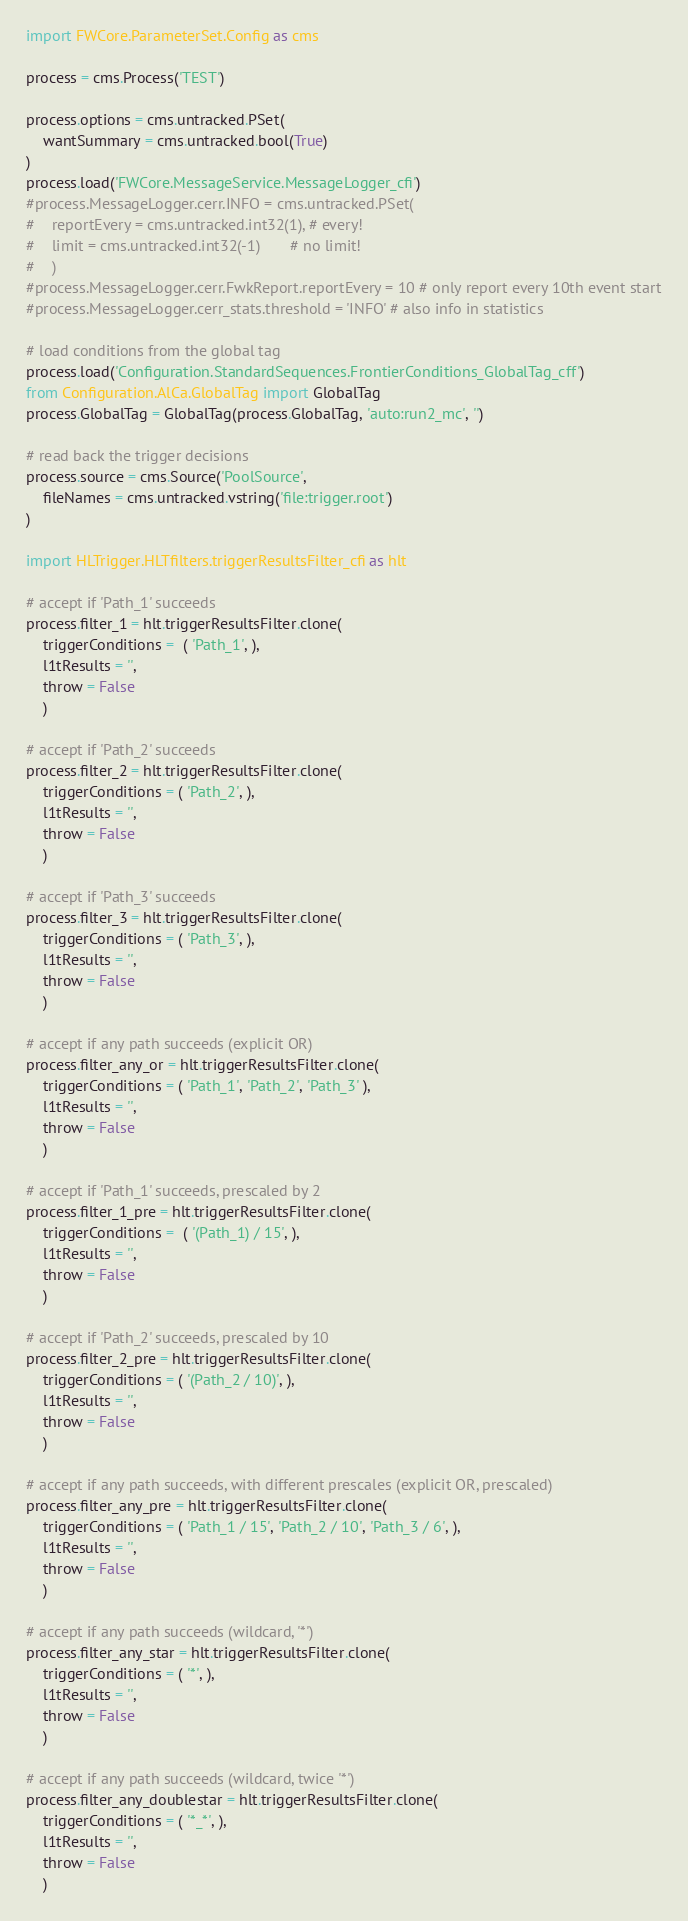<code> <loc_0><loc_0><loc_500><loc_500><_Python_>import FWCore.ParameterSet.Config as cms

process = cms.Process('TEST')

process.options = cms.untracked.PSet(
    wantSummary = cms.untracked.bool(True)
)
process.load('FWCore.MessageService.MessageLogger_cfi')
#process.MessageLogger.cerr.INFO = cms.untracked.PSet(
#    reportEvery = cms.untracked.int32(1), # every!
#    limit = cms.untracked.int32(-1)       # no limit!
#    )
#process.MessageLogger.cerr.FwkReport.reportEvery = 10 # only report every 10th event start
#process.MessageLogger.cerr_stats.threshold = 'INFO' # also info in statistics

# load conditions from the global tag
process.load('Configuration.StandardSequences.FrontierConditions_GlobalTag_cff')
from Configuration.AlCa.GlobalTag import GlobalTag
process.GlobalTag = GlobalTag(process.GlobalTag, 'auto:run2_mc', '')

# read back the trigger decisions
process.source = cms.Source('PoolSource',
    fileNames = cms.untracked.vstring('file:trigger.root')
)

import HLTrigger.HLTfilters.triggerResultsFilter_cfi as hlt

# accept if 'Path_1' succeeds
process.filter_1 = hlt.triggerResultsFilter.clone(
    triggerConditions =  ( 'Path_1', ),
    l1tResults = '',
    throw = False
    )

# accept if 'Path_2' succeeds
process.filter_2 = hlt.triggerResultsFilter.clone(
    triggerConditions = ( 'Path_2', ),
    l1tResults = '',
    throw = False
    )

# accept if 'Path_3' succeeds
process.filter_3 = hlt.triggerResultsFilter.clone(
    triggerConditions = ( 'Path_3', ),
    l1tResults = '',
    throw = False
    )

# accept if any path succeeds (explicit OR)
process.filter_any_or = hlt.triggerResultsFilter.clone(
    triggerConditions = ( 'Path_1', 'Path_2', 'Path_3' ),
    l1tResults = '',
    throw = False
    )

# accept if 'Path_1' succeeds, prescaled by 2
process.filter_1_pre = hlt.triggerResultsFilter.clone(
    triggerConditions =  ( '(Path_1) / 15', ),
    l1tResults = '',
    throw = False
    )

# accept if 'Path_2' succeeds, prescaled by 10
process.filter_2_pre = hlt.triggerResultsFilter.clone(
    triggerConditions = ( '(Path_2 / 10)', ),
    l1tResults = '',
    throw = False
    )

# accept if any path succeeds, with different prescales (explicit OR, prescaled)
process.filter_any_pre = hlt.triggerResultsFilter.clone(
    triggerConditions = ( 'Path_1 / 15', 'Path_2 / 10', 'Path_3 / 6', ),
    l1tResults = '',
    throw = False
    )

# accept if any path succeeds (wildcard, '*')
process.filter_any_star = hlt.triggerResultsFilter.clone(
    triggerConditions = ( '*', ),
    l1tResults = '',
    throw = False
    )

# accept if any path succeeds (wildcard, twice '*')
process.filter_any_doublestar = hlt.triggerResultsFilter.clone(
    triggerConditions = ( '*_*', ),
    l1tResults = '',
    throw = False
    )

</code> 